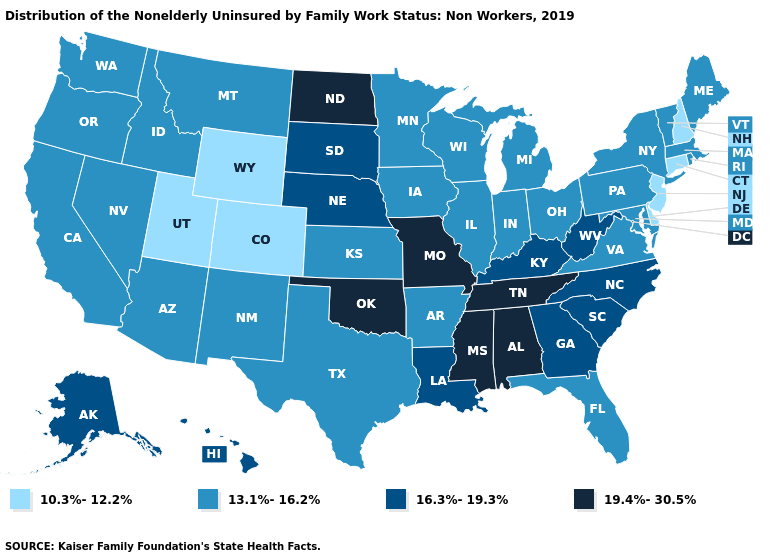What is the value of Massachusetts?
Be succinct. 13.1%-16.2%. What is the value of Rhode Island?
Quick response, please. 13.1%-16.2%. Does Alaska have a higher value than Wyoming?
Keep it brief. Yes. Among the states that border New Mexico , does Utah have the lowest value?
Give a very brief answer. Yes. Does New Jersey have the lowest value in the USA?
Write a very short answer. Yes. What is the value of Minnesota?
Keep it brief. 13.1%-16.2%. What is the value of Colorado?
Keep it brief. 10.3%-12.2%. What is the highest value in the South ?
Quick response, please. 19.4%-30.5%. What is the highest value in the Northeast ?
Concise answer only. 13.1%-16.2%. Does Wyoming have the lowest value in the USA?
Quick response, please. Yes. Name the states that have a value in the range 13.1%-16.2%?
Quick response, please. Arizona, Arkansas, California, Florida, Idaho, Illinois, Indiana, Iowa, Kansas, Maine, Maryland, Massachusetts, Michigan, Minnesota, Montana, Nevada, New Mexico, New York, Ohio, Oregon, Pennsylvania, Rhode Island, Texas, Vermont, Virginia, Washington, Wisconsin. Which states have the lowest value in the USA?
Quick response, please. Colorado, Connecticut, Delaware, New Hampshire, New Jersey, Utah, Wyoming. What is the value of Mississippi?
Keep it brief. 19.4%-30.5%. Name the states that have a value in the range 13.1%-16.2%?
Write a very short answer. Arizona, Arkansas, California, Florida, Idaho, Illinois, Indiana, Iowa, Kansas, Maine, Maryland, Massachusetts, Michigan, Minnesota, Montana, Nevada, New Mexico, New York, Ohio, Oregon, Pennsylvania, Rhode Island, Texas, Vermont, Virginia, Washington, Wisconsin. 